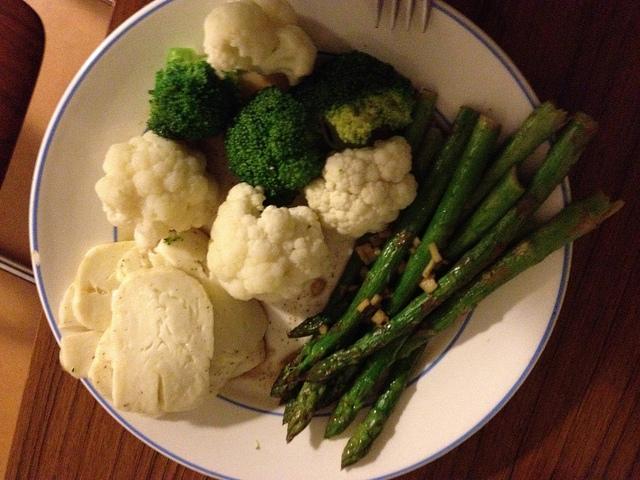Is this an vegetarian voice?
Be succinct. Yes. Is the fork on the correct side?
Concise answer only. No. Are there green veggies on the plate?
Give a very brief answer. Yes. How many pieces of cauliflower are in this pan?
Short answer required. 4. How many different types of vegetable are there?
Give a very brief answer. 3. Is this food cooked?
Keep it brief. Yes. 